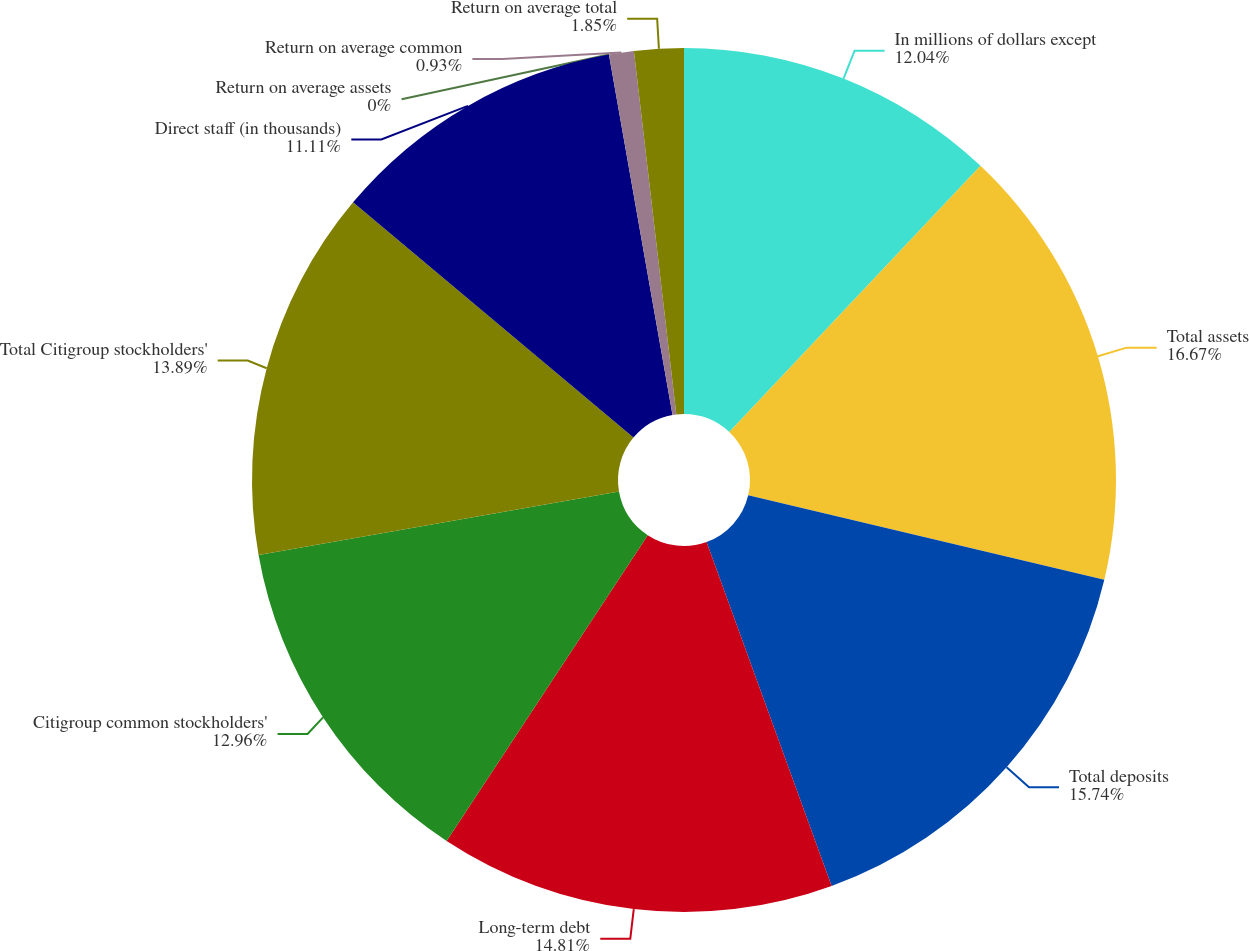<chart> <loc_0><loc_0><loc_500><loc_500><pie_chart><fcel>In millions of dollars except<fcel>Total assets<fcel>Total deposits<fcel>Long-term debt<fcel>Citigroup common stockholders'<fcel>Total Citigroup stockholders'<fcel>Direct staff (in thousands)<fcel>Return on average assets<fcel>Return on average common<fcel>Return on average total<nl><fcel>12.04%<fcel>16.67%<fcel>15.74%<fcel>14.81%<fcel>12.96%<fcel>13.89%<fcel>11.11%<fcel>0.0%<fcel>0.93%<fcel>1.85%<nl></chart> 